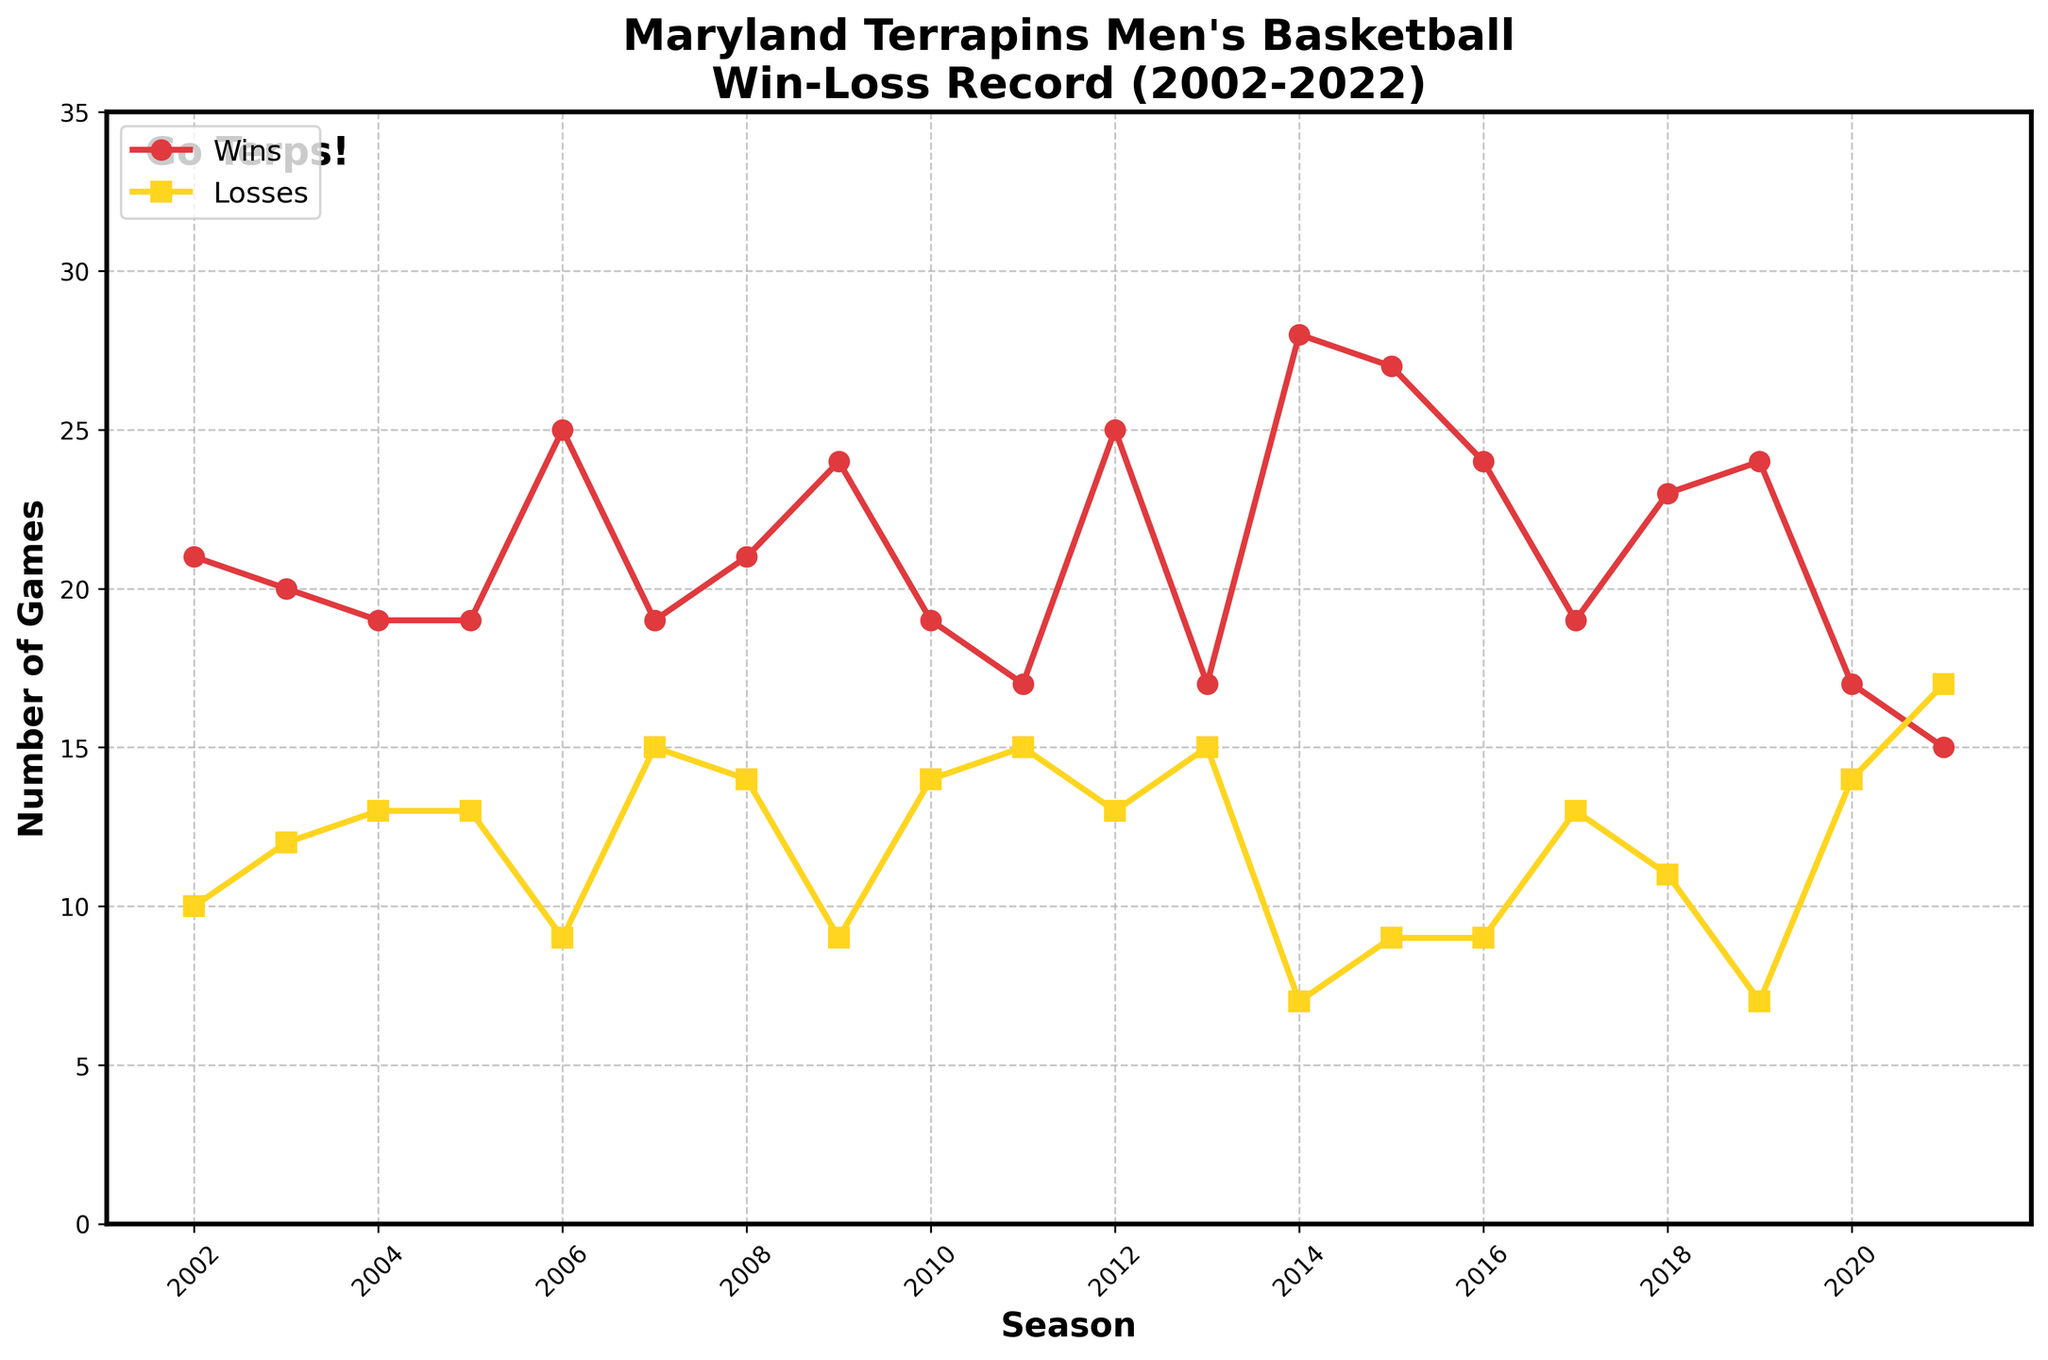Which season had the highest number of wins for Maryland Terrapins men's basketball? To determine the season with the highest number of wins, identify the peak point on the 'Wins' line. The highest point is in the 2014-15 season.
Answer: 2014-15 How many seasons did Maryland win more than 25 games? Look for the 'Wins' line points that are above 25. These occur in the 2006-07, 2012-13, 2014-15, 2015-16, and 2019-20 seasons.
Answer: 5 What is the difference between the number of wins and losses in the 2009-10 season? Locate the wins and losses for the 2009-10 season from the chart. Wins are 24 and losses are 9. The difference is 24 - 9.
Answer: 15 Which season had the lowest number of wins? Identify the lowest point on the 'Wins' line. The lowest point is in the 2021-22 season.
Answer: 2021-22 In which season did Maryland Terrapins have equal wins and losses? Locate seasons where the 'Wins' and 'Losses' lines intersect or are closest together. The 2004-05 and 2005-06 seasons both had 19 wins and 13 losses.
Answer: None How did the win-loss record change between 2018-19 and 2019-20 seasons? Compare the 'Wins' and 'Losses' lines between these two seasons. Wins increased from 23 to 24 and losses decreased from 11 to 7.
Answer: Increased wins, decreased losses Which color represents the losses in the chart? Observe the color of the line labeled 'Losses' in the legend. The losses are represented by a yellow line.
Answer: Yellow What was the aggregate number of wins over the first five seasons? Sum the wins from 2002-03 to 2006-07 (21 + 20 + 19 + 19 + 25).
Answer: 104 Which season had the smallest difference between wins and losses? Calculate the differences for each season and find the smallest. The smallest difference is 2 in the 2021-22 season.
Answer: 2021-22 How many times did Maryland Terrapins win exactly 19 games in a season? Identify the points on the 'Wins' line that align with 19. The seasons are 2004-05, 2005-06, 2007-08, 2010-11, and 2017-18.
Answer: 5 